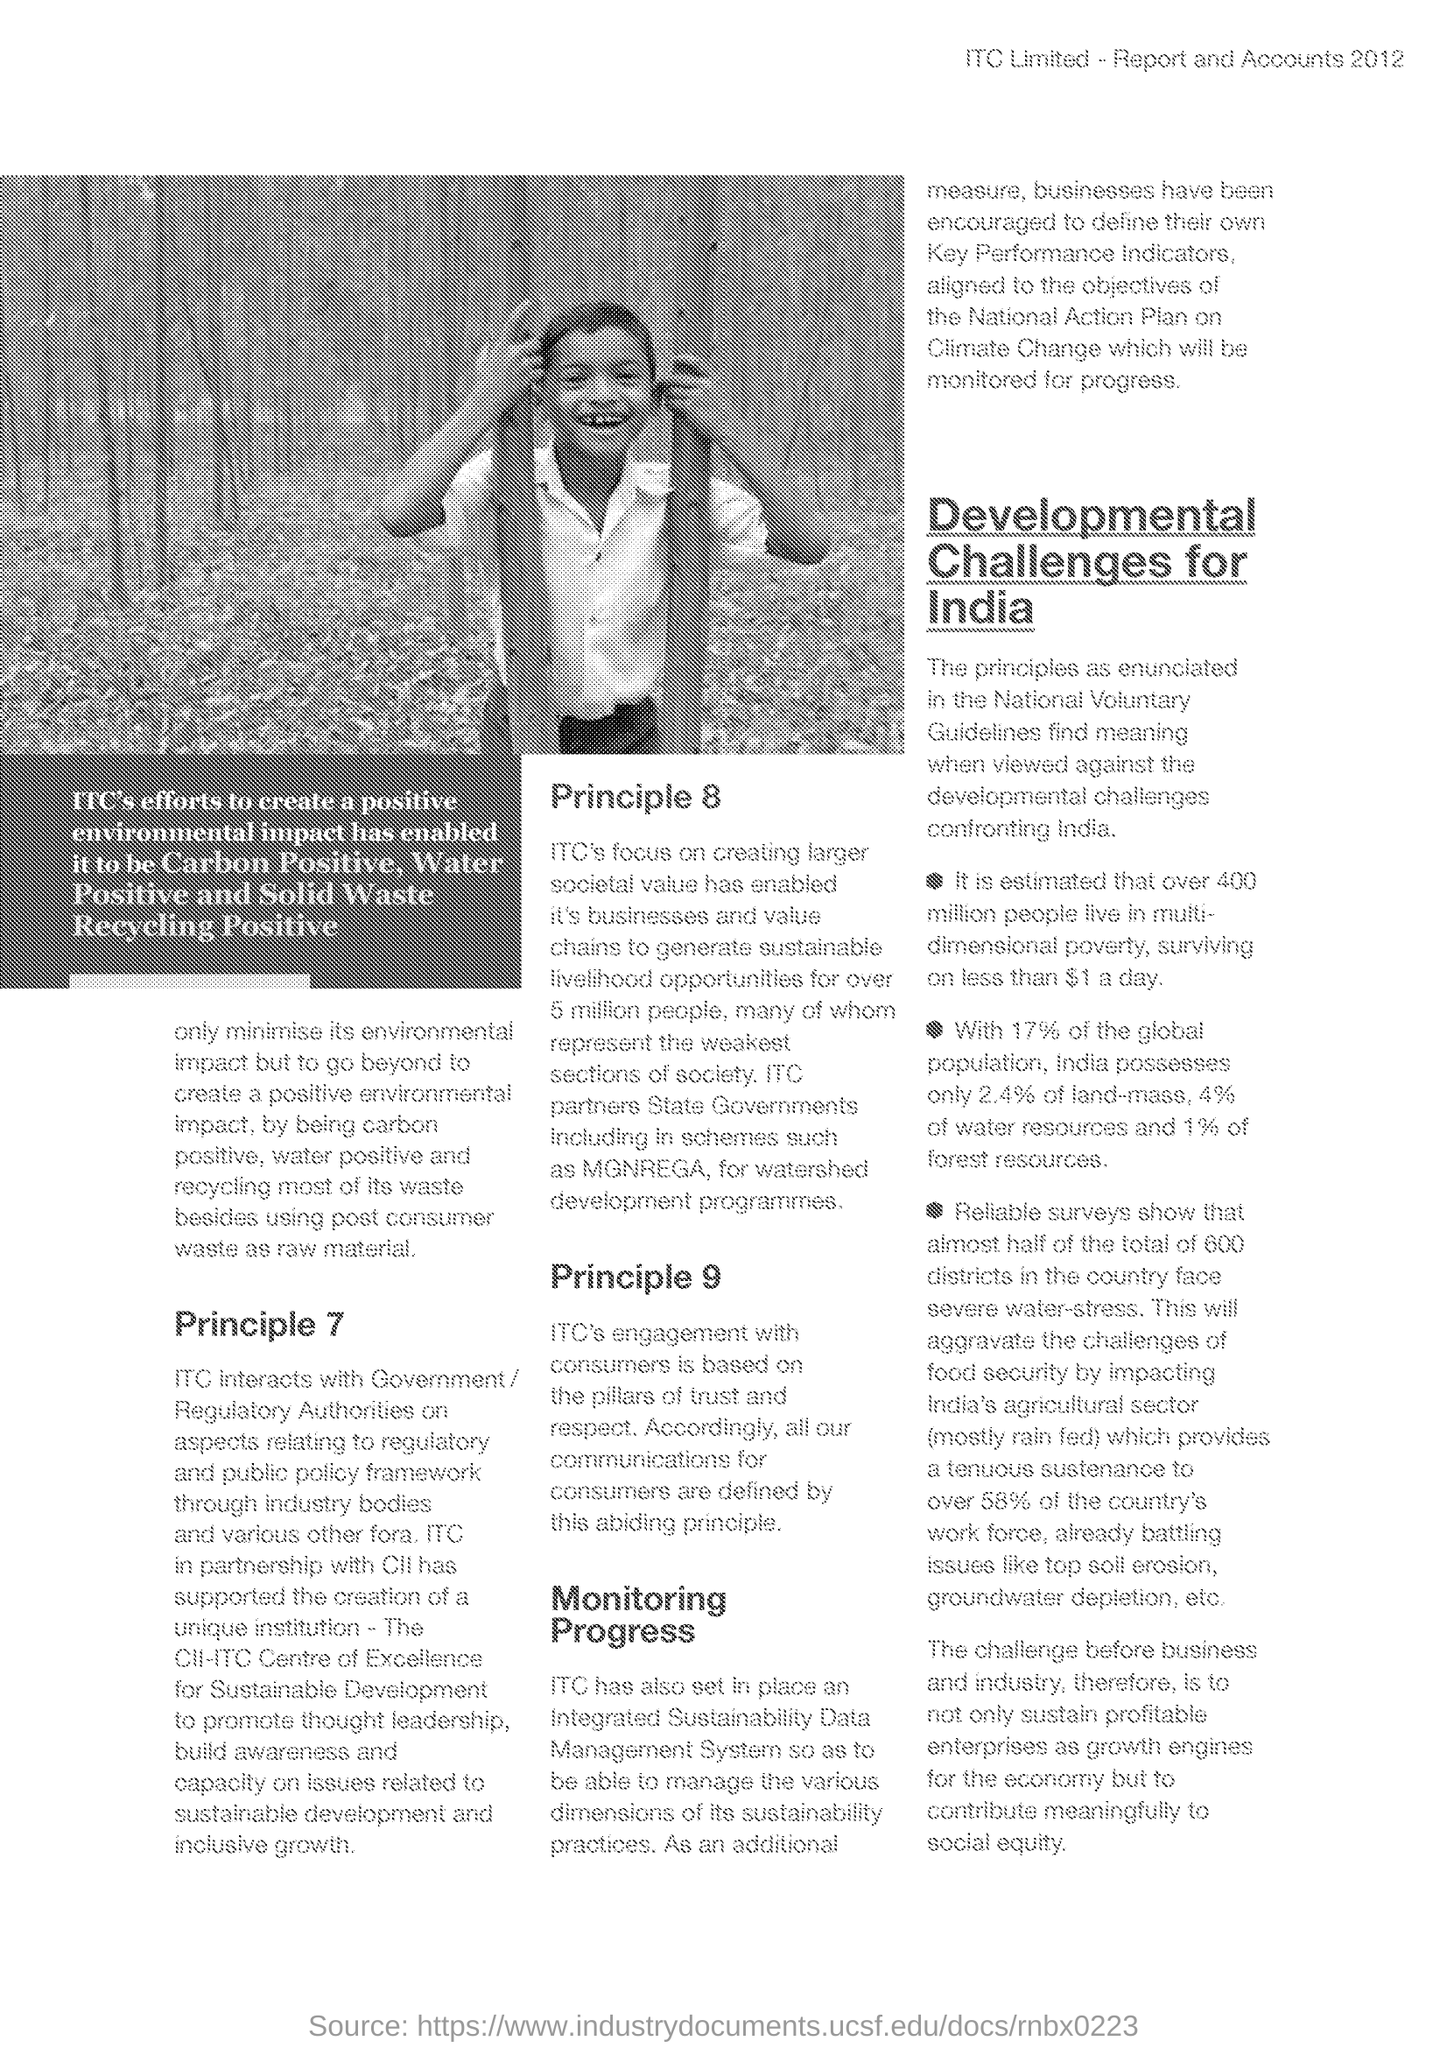"ITC in partnership with" which company "has supported the creation of a unique institution"?
Your answer should be compact. Cii. "In which scheme ITC partners with State Government"  for watershed development programmes?
Provide a short and direct response. MGNREGA. "ITC's engagement with whom "is based on the pillars of trust and respect"?
Your answer should be compact. Consumers. "Development challenges for" which country is given in the document?
Your response must be concise. India. "India possesses" what percentage "of the global population"?
Offer a very short reply. 17. "India possesses" what percentage "of land-mass"?
Provide a short and direct response. 2.4. "India possesses" what percentage "of water resources"?
Offer a terse response. 4%. "India possesses" what percentage "of forest resources"?
Your answer should be very brief. 1. 